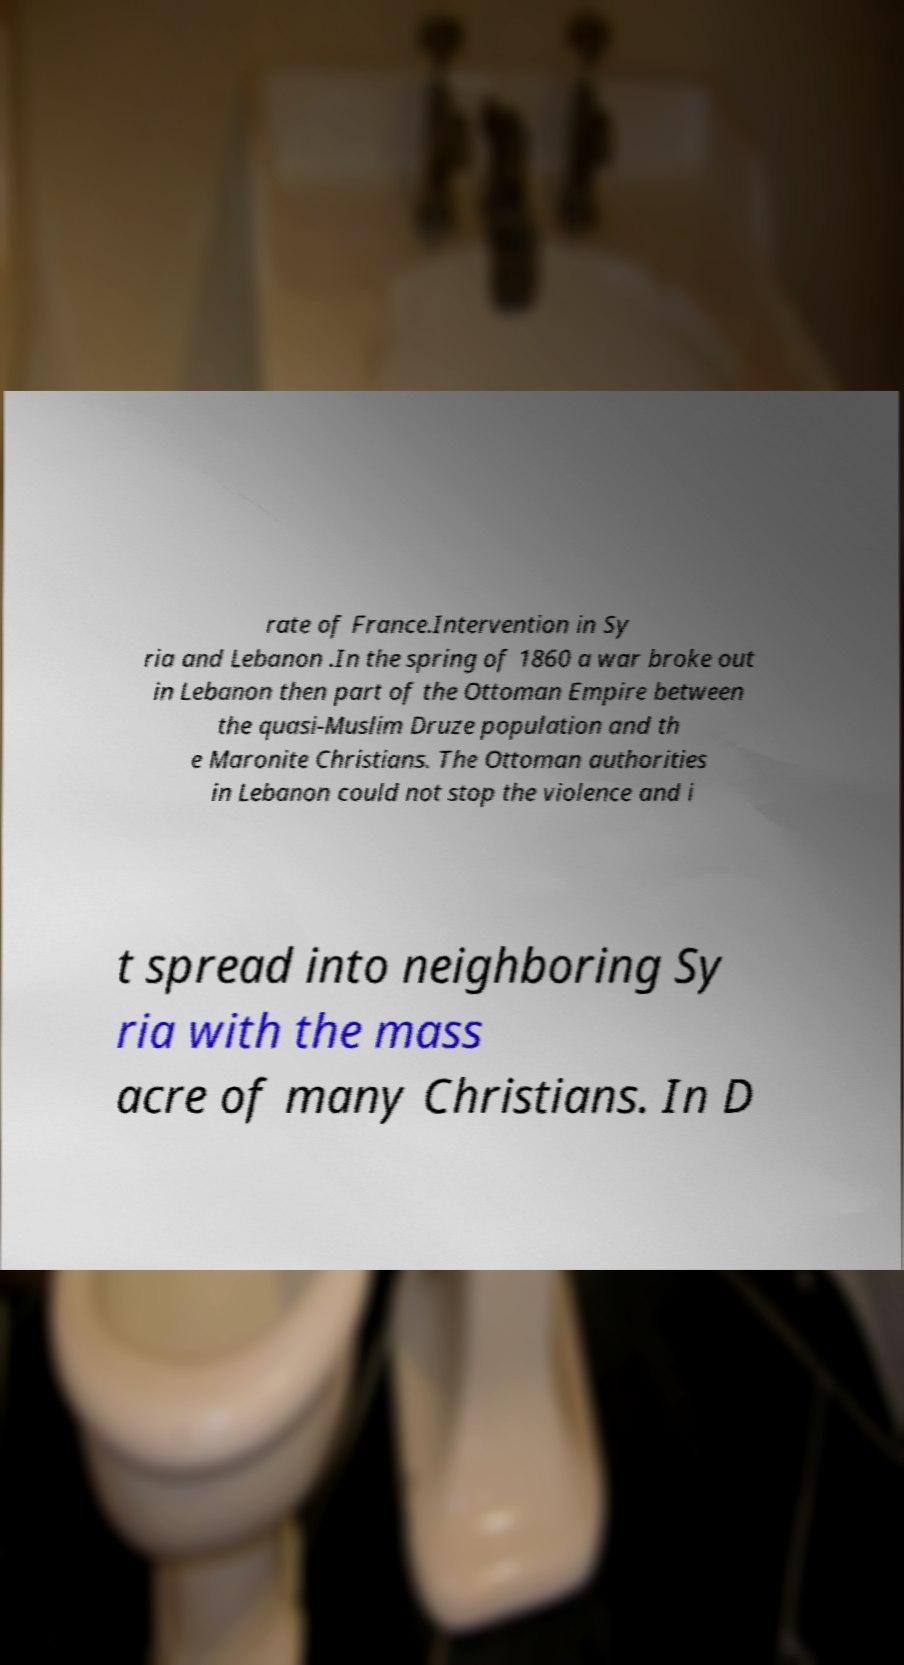What messages or text are displayed in this image? I need them in a readable, typed format. rate of France.Intervention in Sy ria and Lebanon .In the spring of 1860 a war broke out in Lebanon then part of the Ottoman Empire between the quasi-Muslim Druze population and th e Maronite Christians. The Ottoman authorities in Lebanon could not stop the violence and i t spread into neighboring Sy ria with the mass acre of many Christians. In D 